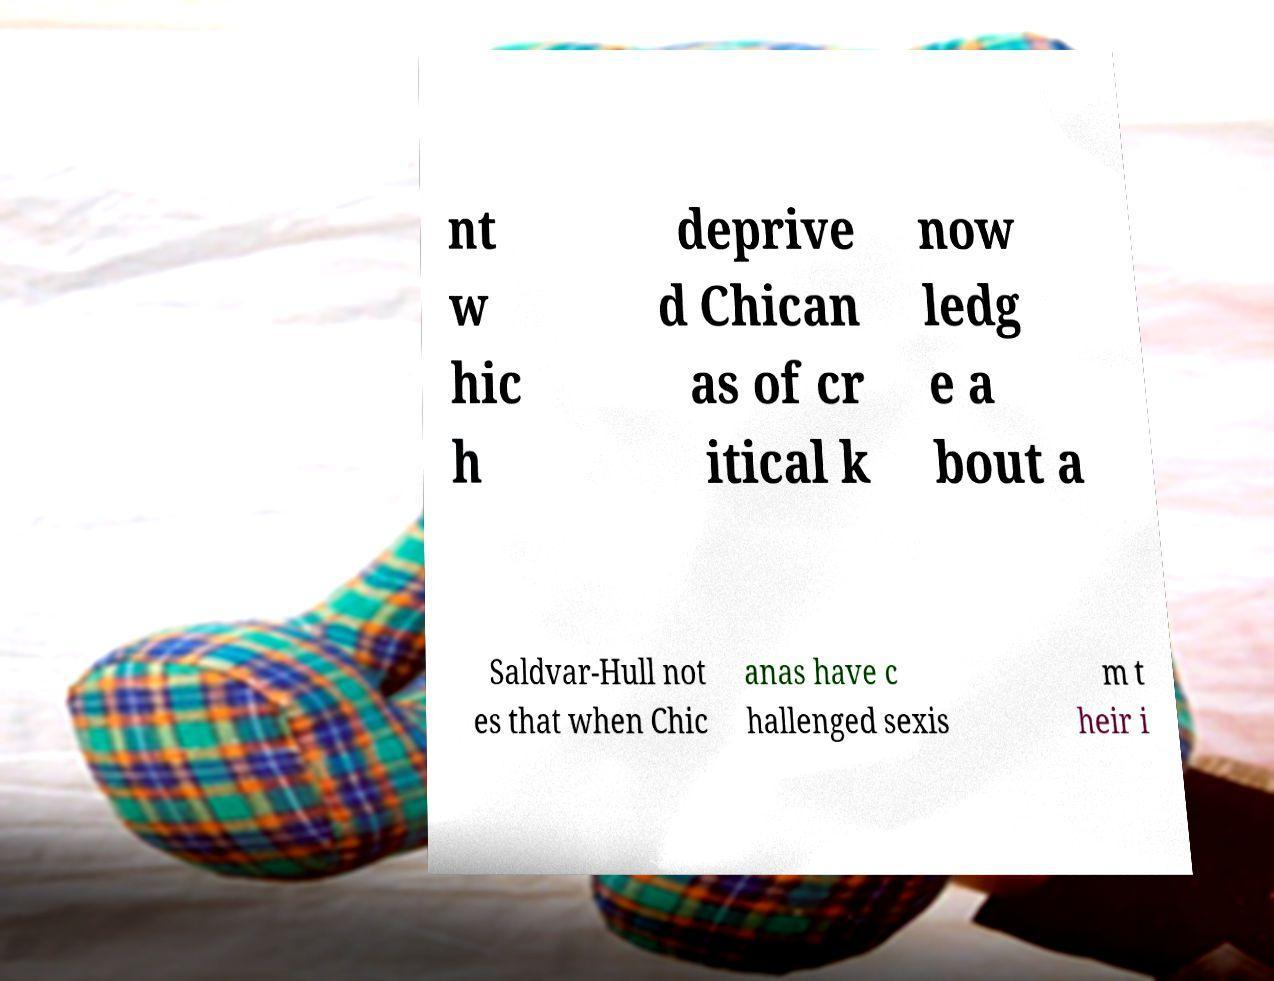For documentation purposes, I need the text within this image transcribed. Could you provide that? nt w hic h deprive d Chican as of cr itical k now ledg e a bout a Saldvar-Hull not es that when Chic anas have c hallenged sexis m t heir i 